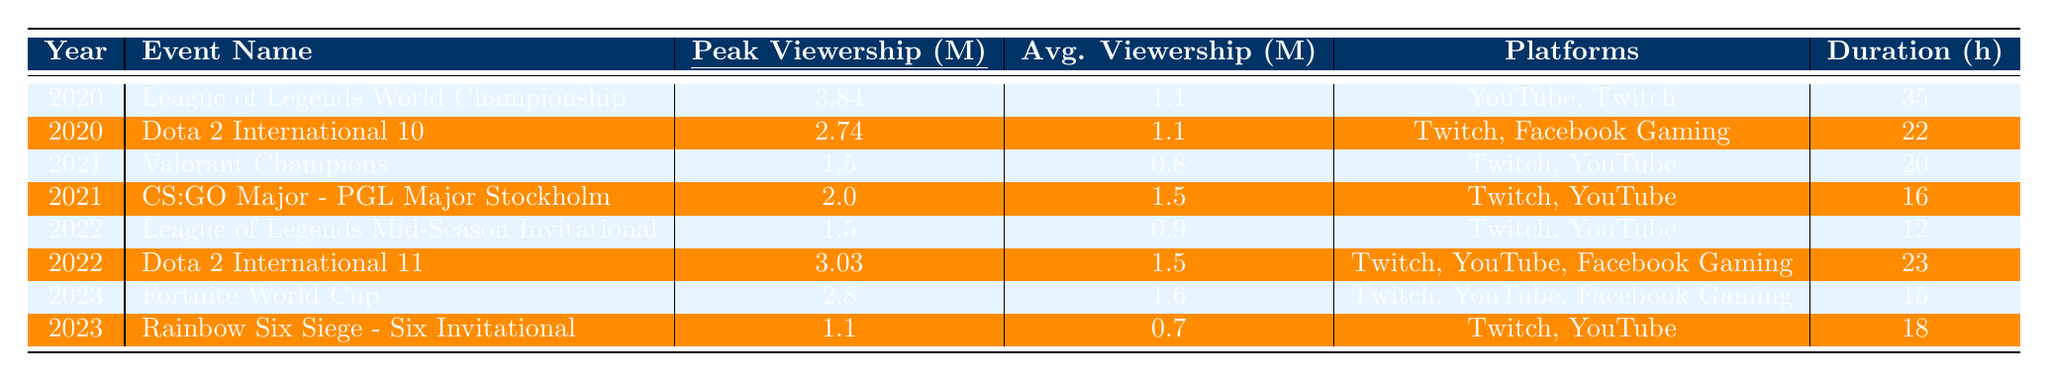What was the peak viewership for the League of Legends World Championship in 2020? The table shows the peak viewership for the League of Legends World Championship in 2020 as 3.84 million.
Answer: 3.84 million Which event had the highest average viewership in 2022? The peak viewership for Dota 2 International 11 in 2022 was 3.03 million, with an average viewership of 1.5 million, which is the highest average viewership compared to 1.5 million for League of Legends Mid-Season Invitational, which had a lower peak.
Answer: Dota 2 International 11 What is the total duration in hours for all esports events held in 2021? Summing the durations: Valorant Champions (20 hours) + CS:GO Major - PGL Major Stockholm (16 hours) gives a total of 36 hours for events in 2021.
Answer: 36 hours Did the average viewership for the Rainbow Six Siege - Six Invitational in 2023 exceed 1 million? The average viewership for Rainbow Six Siege - Six Invitational is noted as 0.7 million, which is less than 1 million.
Answer: No What is the difference in peak viewership between Dota 2 International 10 and League of Legends World Championship in 2020? The peak viewership for Dota 2 International 10 is 2.74 million and for League of Legends World Championship is 3.84 million. The difference is calculated as 3.84 - 2.74 = 1.1 million.
Answer: 1.1 million Which platform was used for broadcasting the events in both 2020 and 2022? The table lists Twitch as a common platform used in both 2020 and 2022 events, including both Dota 2 International events and League of Legends events.
Answer: Twitch What was the average viewership for all events in 2023? The average viewership for Fortnite World Cup (1.6 million) and Rainbow Six Siege - Six Invitational (0.7 million) is calculated as (1.6 + 0.7) / 2 = 1.15 million.
Answer: 1.15 million How many esports events had a peak viewership of over 2 million? From the table, League of Legends World Championship (3.84 million) and Dota 2 International 11 (3.03 million) had peak viewership over 2 million, totaling 2 events.
Answer: 2 events Was the peak viewership for the Fortnite World Cup in 2023 higher than the average viewership for the event? The peak viewership for Fortnite World Cup is 2.8 million and the average viewership is 1.6 million, hence the peak viewership is higher than the average.
Answer: Yes Identify the event with the shortest duration in hours from 2022. From the table, the League of Legends Mid-Season Invitational had the shortest duration of 12 hours compared to 23 hours for Dota 2 International 11.
Answer: League of Legends Mid-Season Invitational 